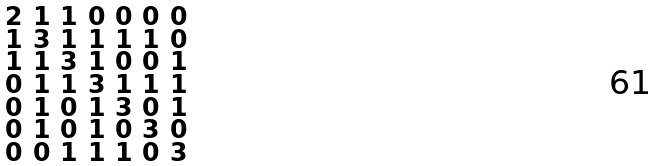<formula> <loc_0><loc_0><loc_500><loc_500>\begin{smallmatrix} 2 & 1 & 1 & 0 & 0 & 0 & 0 \\ 1 & 3 & 1 & 1 & 1 & 1 & 0 \\ 1 & 1 & 3 & 1 & 0 & 0 & 1 \\ 0 & 1 & 1 & 3 & 1 & 1 & 1 \\ 0 & 1 & 0 & 1 & 3 & 0 & 1 \\ 0 & 1 & 0 & 1 & 0 & 3 & 0 \\ 0 & 0 & 1 & 1 & 1 & 0 & 3 \end{smallmatrix}</formula> 